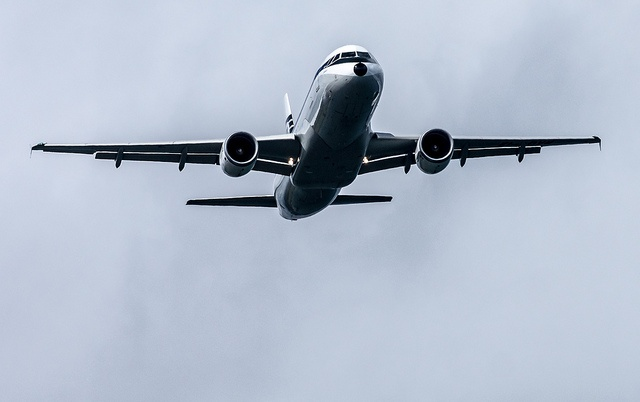Describe the objects in this image and their specific colors. I can see a airplane in lavender, black, lightgray, darkgray, and gray tones in this image. 